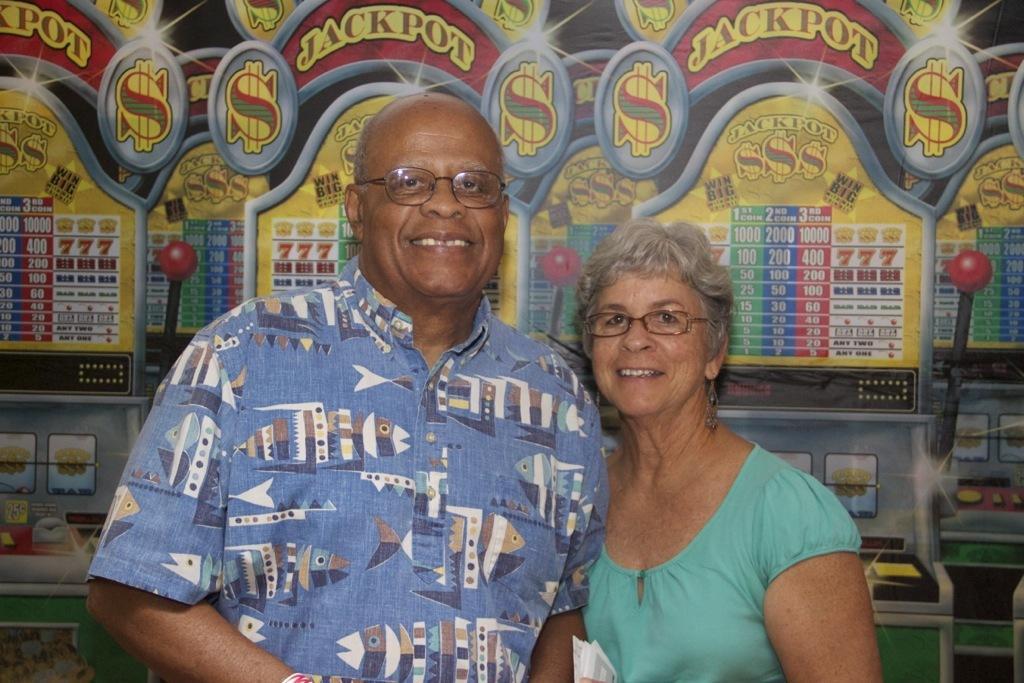Can you describe this image briefly? In this image we can see two persons. Behind the persons we can see gaming consoles truncated. 